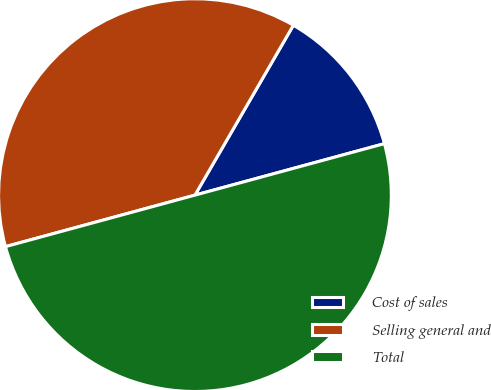Convert chart to OTSL. <chart><loc_0><loc_0><loc_500><loc_500><pie_chart><fcel>Cost of sales<fcel>Selling general and<fcel>Total<nl><fcel>12.42%<fcel>37.58%<fcel>50.0%<nl></chart> 